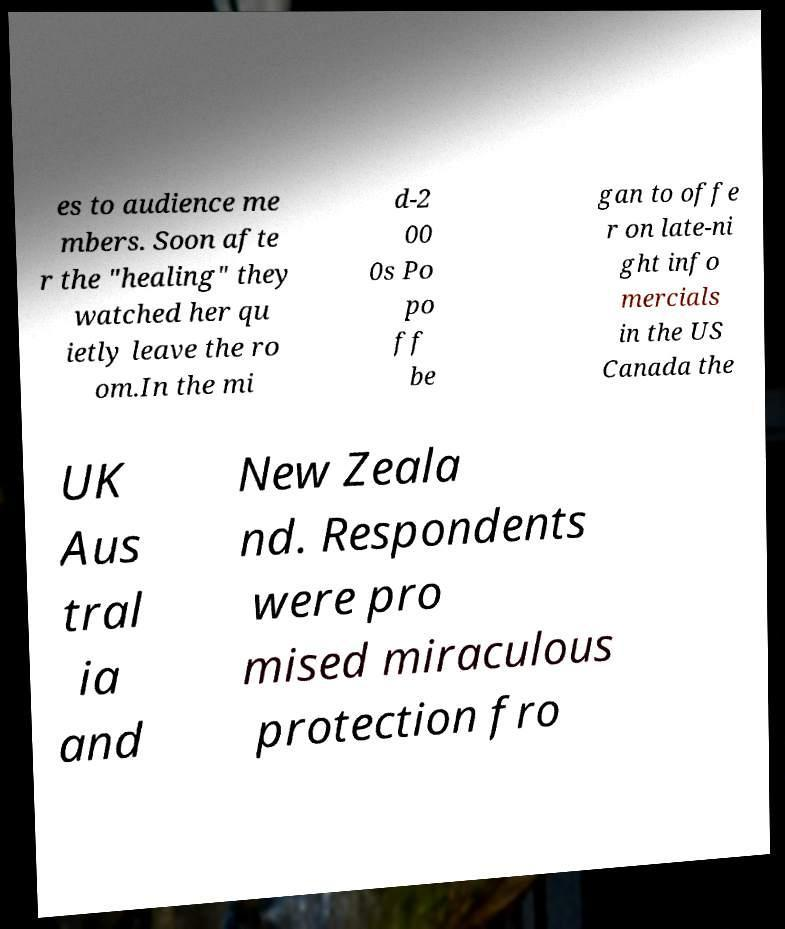What messages or text are displayed in this image? I need them in a readable, typed format. es to audience me mbers. Soon afte r the "healing" they watched her qu ietly leave the ro om.In the mi d-2 00 0s Po po ff be gan to offe r on late-ni ght info mercials in the US Canada the UK Aus tral ia and New Zeala nd. Respondents were pro mised miraculous protection fro 